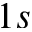<formula> <loc_0><loc_0><loc_500><loc_500>1 s</formula> 